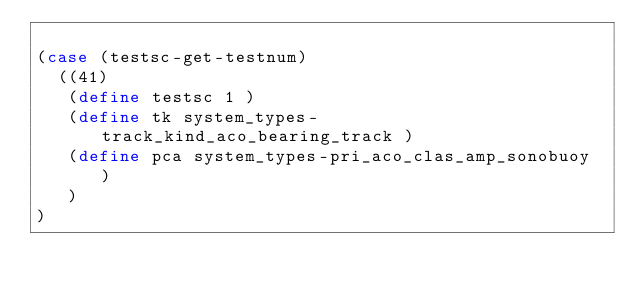<code> <loc_0><loc_0><loc_500><loc_500><_Scheme_>
(case (testsc-get-testnum)
  ((41)
   (define testsc 1 )
   (define tk system_types-track_kind_aco_bearing_track )
   (define pca system_types-pri_aco_clas_amp_sonobuoy )
   )
)
</code> 